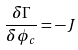<formula> <loc_0><loc_0><loc_500><loc_500>\frac { \delta \Gamma } { \delta \phi _ { c } } = - J</formula> 